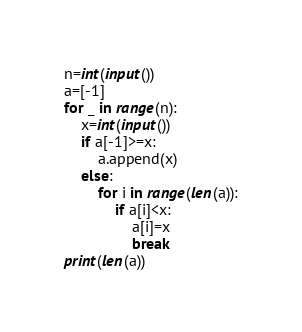<code> <loc_0><loc_0><loc_500><loc_500><_Python_>n=int(input())
a=[-1]
for _ in range(n):
    x=int(input())
    if a[-1]>=x:
        a.append(x)
    else:
        for i in range(len(a)):
            if a[i]<x:
                a[i]=x
                break
print(len(a))</code> 